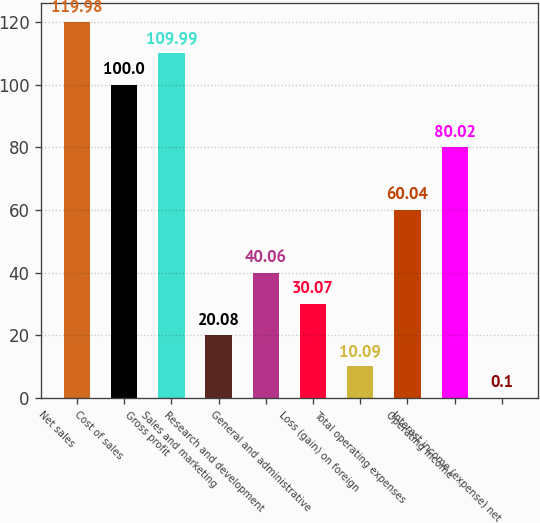<chart> <loc_0><loc_0><loc_500><loc_500><bar_chart><fcel>Net sales<fcel>Cost of sales<fcel>Gross profit<fcel>Sales and marketing<fcel>Research and development<fcel>General and administrative<fcel>Loss (gain) on foreign<fcel>Total operating expenses<fcel>Operating income<fcel>Interest income (expense) net<nl><fcel>119.98<fcel>100<fcel>109.99<fcel>20.08<fcel>40.06<fcel>30.07<fcel>10.09<fcel>60.04<fcel>80.02<fcel>0.1<nl></chart> 